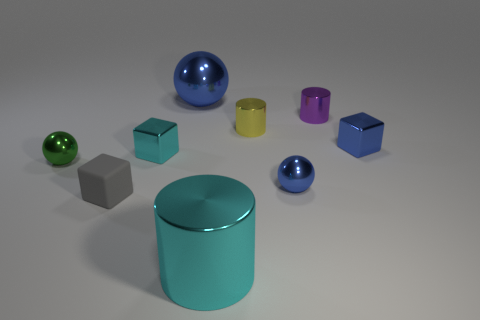There is a tiny shiny block left of the big thing in front of the tiny purple cylinder; is there a green sphere that is behind it?
Offer a terse response. No. How many big cylinders are the same material as the tiny purple object?
Provide a succinct answer. 1. There is a blue sphere that is in front of the small purple cylinder; is it the same size as the blue object that is on the left side of the big cyan metal cylinder?
Offer a very short reply. No. The cube to the right of the small blue metal thing that is in front of the tiny thing on the left side of the small gray object is what color?
Your answer should be compact. Blue. Are there any other rubber things of the same shape as the tiny cyan object?
Your answer should be compact. Yes. Is the number of gray rubber blocks that are in front of the small gray matte block the same as the number of cylinders on the left side of the tiny cyan metallic thing?
Your response must be concise. Yes. Do the cyan shiny thing behind the gray matte thing and the green object have the same shape?
Give a very brief answer. No. Is the green thing the same shape as the big cyan object?
Offer a terse response. No. How many rubber things are either cyan blocks or tiny brown spheres?
Your answer should be compact. 0. There is a small cube that is the same color as the big ball; what material is it?
Offer a terse response. Metal. 